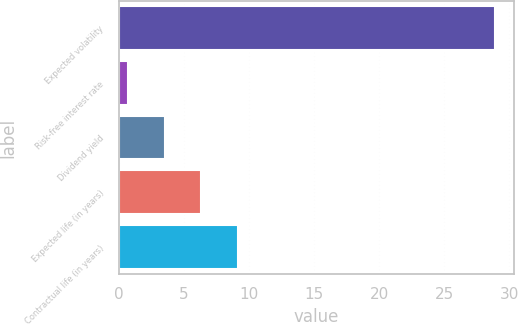<chart> <loc_0><loc_0><loc_500><loc_500><bar_chart><fcel>Expected volatility<fcel>Risk-free interest rate<fcel>Dividend yield<fcel>Expected life (in years)<fcel>Contractual life (in years)<nl><fcel>28.9<fcel>0.7<fcel>3.52<fcel>6.34<fcel>9.16<nl></chart> 